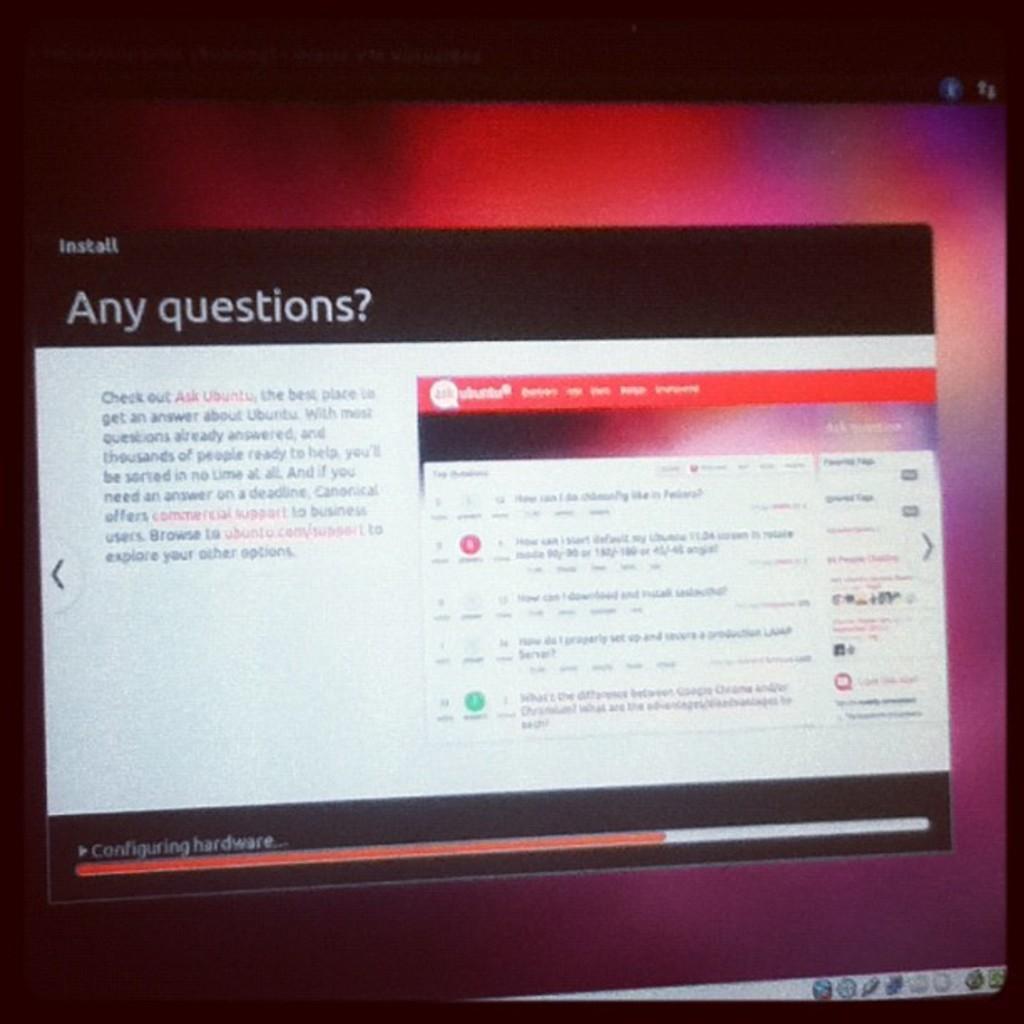Can you describe this image briefly? The picture is taken from the desktop monitor and there is a popup screen on the monitor. 